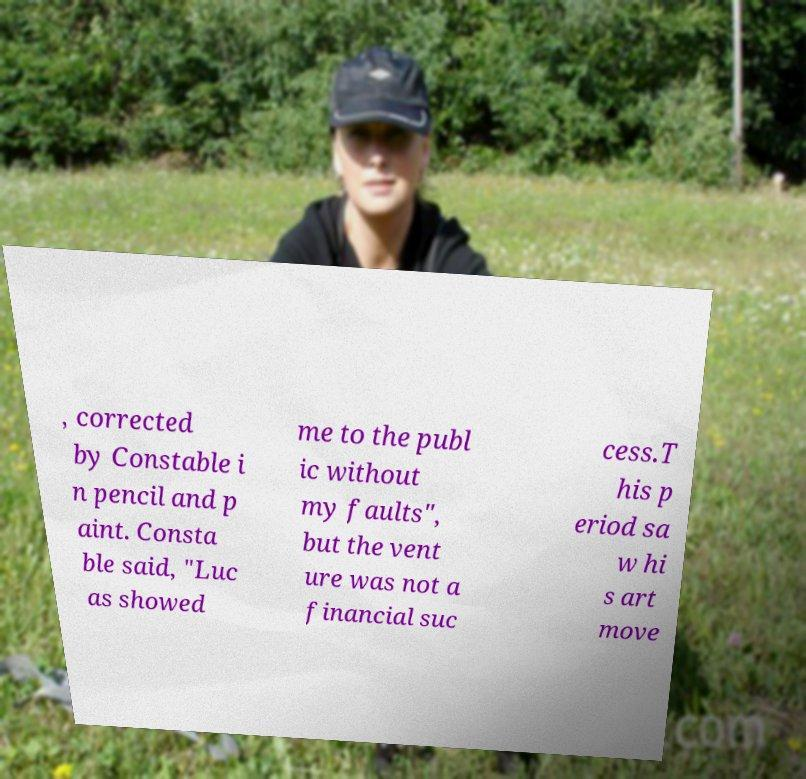Could you assist in decoding the text presented in this image and type it out clearly? , corrected by Constable i n pencil and p aint. Consta ble said, "Luc as showed me to the publ ic without my faults", but the vent ure was not a financial suc cess.T his p eriod sa w hi s art move 